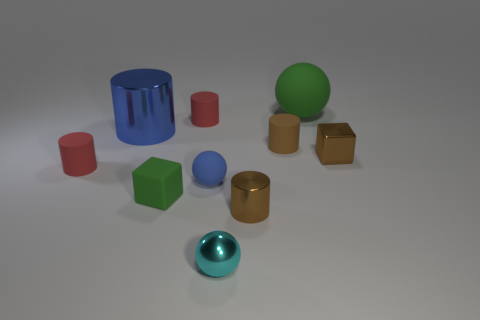Can you describe the lighting in the scene and how it affects the appearance of the objects? The lighting in the scene is soft and diffuse, coming from above. It creates gentle shadows and highlights the curvature of the objects, adding depth to the image. The reflective objects show distinct light reflections, while the matte objects absorb more light, resulting in less pronounced highlights. 